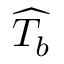Convert formula to latex. <formula><loc_0><loc_0><loc_500><loc_500>\widehat { T _ { b } }</formula> 